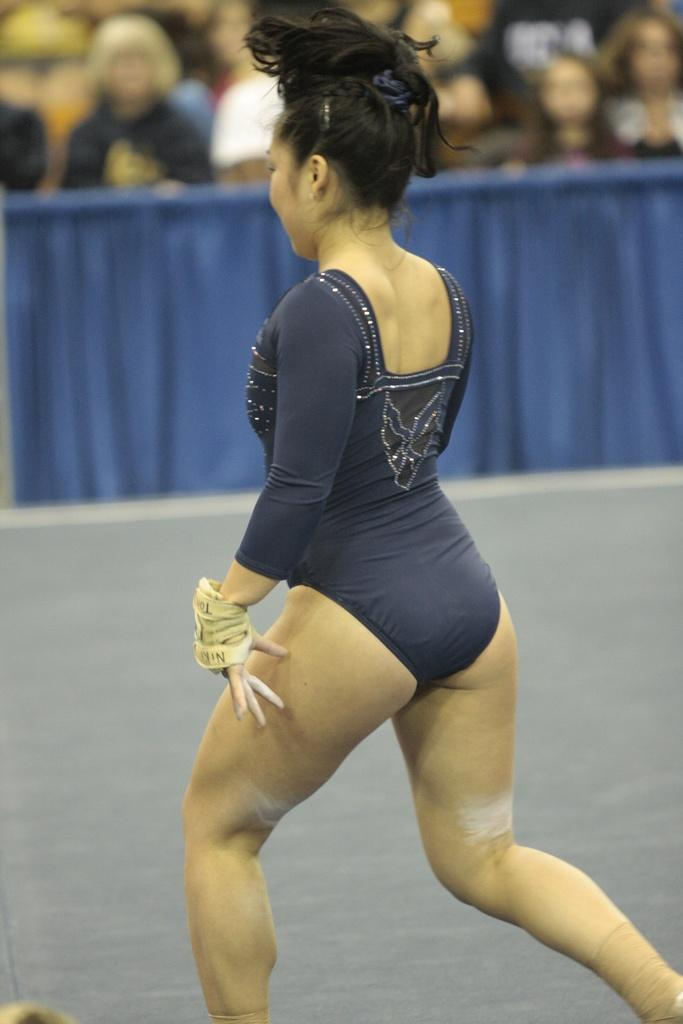What is happening in the foreground of the image? There is a woman walking in the foreground of the image. What surface is the woman walking on? The woman is walking on the ground. What can be seen in the background of the image? There is a fence and a group of people in the background of the image. Can you describe the time of day when the image was taken? The image was likely taken during the day, as there is sufficient light to see the details clearly. How many legs does the woman have in the image? The woman has two legs, as humans typically have two legs. However, this information cannot be directly determined from the image itself. 